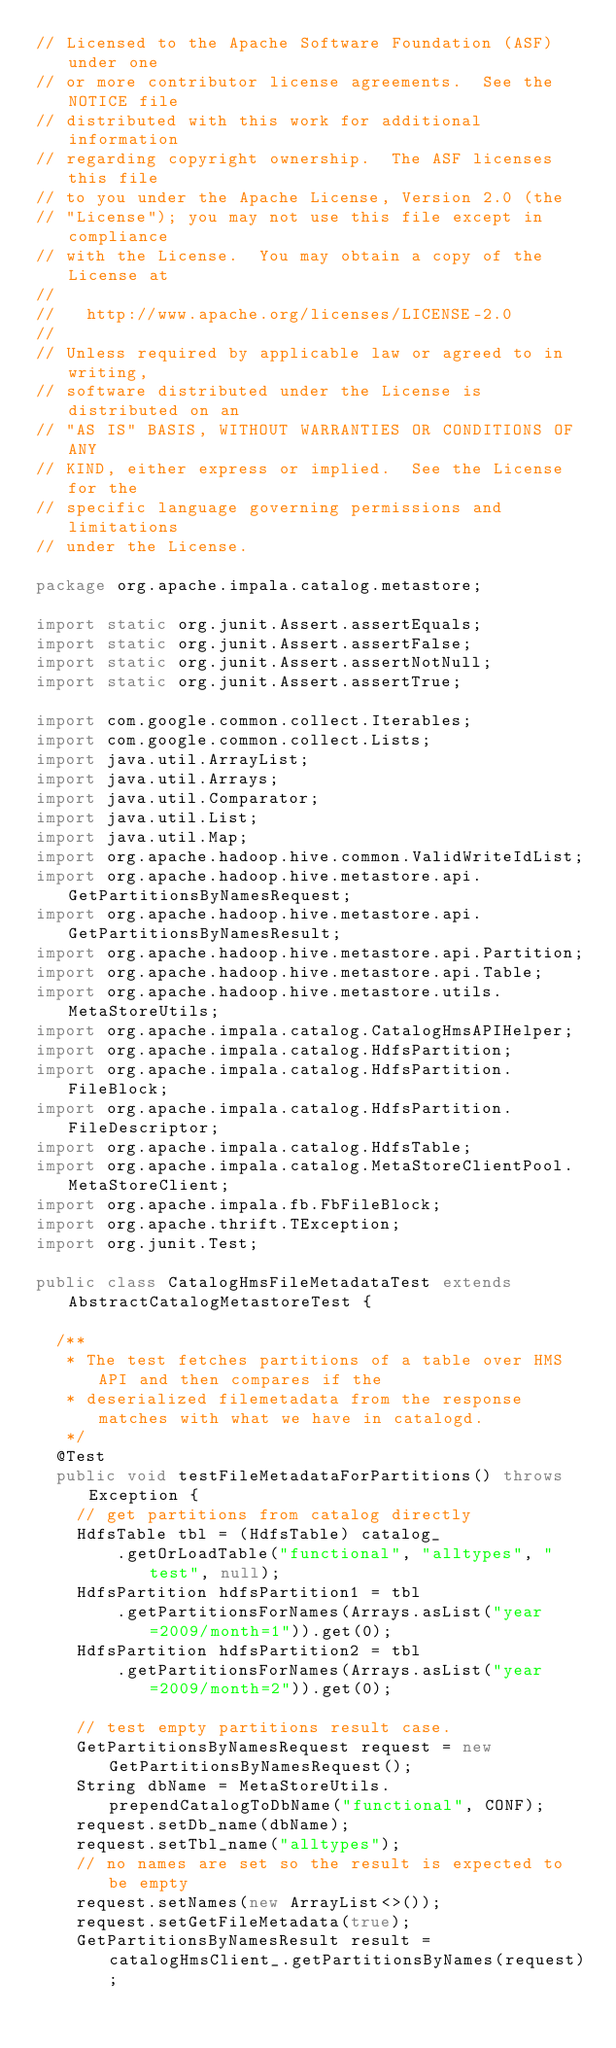<code> <loc_0><loc_0><loc_500><loc_500><_Java_>// Licensed to the Apache Software Foundation (ASF) under one
// or more contributor license agreements.  See the NOTICE file
// distributed with this work for additional information
// regarding copyright ownership.  The ASF licenses this file
// to you under the Apache License, Version 2.0 (the
// "License"); you may not use this file except in compliance
// with the License.  You may obtain a copy of the License at
//
//   http://www.apache.org/licenses/LICENSE-2.0
//
// Unless required by applicable law or agreed to in writing,
// software distributed under the License is distributed on an
// "AS IS" BASIS, WITHOUT WARRANTIES OR CONDITIONS OF ANY
// KIND, either express or implied.  See the License for the
// specific language governing permissions and limitations
// under the License.

package org.apache.impala.catalog.metastore;

import static org.junit.Assert.assertEquals;
import static org.junit.Assert.assertFalse;
import static org.junit.Assert.assertNotNull;
import static org.junit.Assert.assertTrue;

import com.google.common.collect.Iterables;
import com.google.common.collect.Lists;
import java.util.ArrayList;
import java.util.Arrays;
import java.util.Comparator;
import java.util.List;
import java.util.Map;
import org.apache.hadoop.hive.common.ValidWriteIdList;
import org.apache.hadoop.hive.metastore.api.GetPartitionsByNamesRequest;
import org.apache.hadoop.hive.metastore.api.GetPartitionsByNamesResult;
import org.apache.hadoop.hive.metastore.api.Partition;
import org.apache.hadoop.hive.metastore.api.Table;
import org.apache.hadoop.hive.metastore.utils.MetaStoreUtils;
import org.apache.impala.catalog.CatalogHmsAPIHelper;
import org.apache.impala.catalog.HdfsPartition;
import org.apache.impala.catalog.HdfsPartition.FileBlock;
import org.apache.impala.catalog.HdfsPartition.FileDescriptor;
import org.apache.impala.catalog.HdfsTable;
import org.apache.impala.catalog.MetaStoreClientPool.MetaStoreClient;
import org.apache.impala.fb.FbFileBlock;
import org.apache.thrift.TException;
import org.junit.Test;

public class CatalogHmsFileMetadataTest extends AbstractCatalogMetastoreTest {

  /**
   * The test fetches partitions of a table over HMS API and then compares if the
   * deserialized filemetadata from the response matches with what we have in catalogd.
   */
  @Test
  public void testFileMetadataForPartitions() throws Exception {
    // get partitions from catalog directly
    HdfsTable tbl = (HdfsTable) catalog_
        .getOrLoadTable("functional", "alltypes", "test", null);
    HdfsPartition hdfsPartition1 = tbl
        .getPartitionsForNames(Arrays.asList("year=2009/month=1")).get(0);
    HdfsPartition hdfsPartition2 = tbl
        .getPartitionsForNames(Arrays.asList("year=2009/month=2")).get(0);

    // test empty partitions result case.
    GetPartitionsByNamesRequest request = new GetPartitionsByNamesRequest();
    String dbName = MetaStoreUtils.prependCatalogToDbName("functional", CONF);
    request.setDb_name(dbName);
    request.setTbl_name("alltypes");
    // no names are set so the result is expected to be empty
    request.setNames(new ArrayList<>());
    request.setGetFileMetadata(true);
    GetPartitionsByNamesResult result = catalogHmsClient_.getPartitionsByNames(request);</code> 